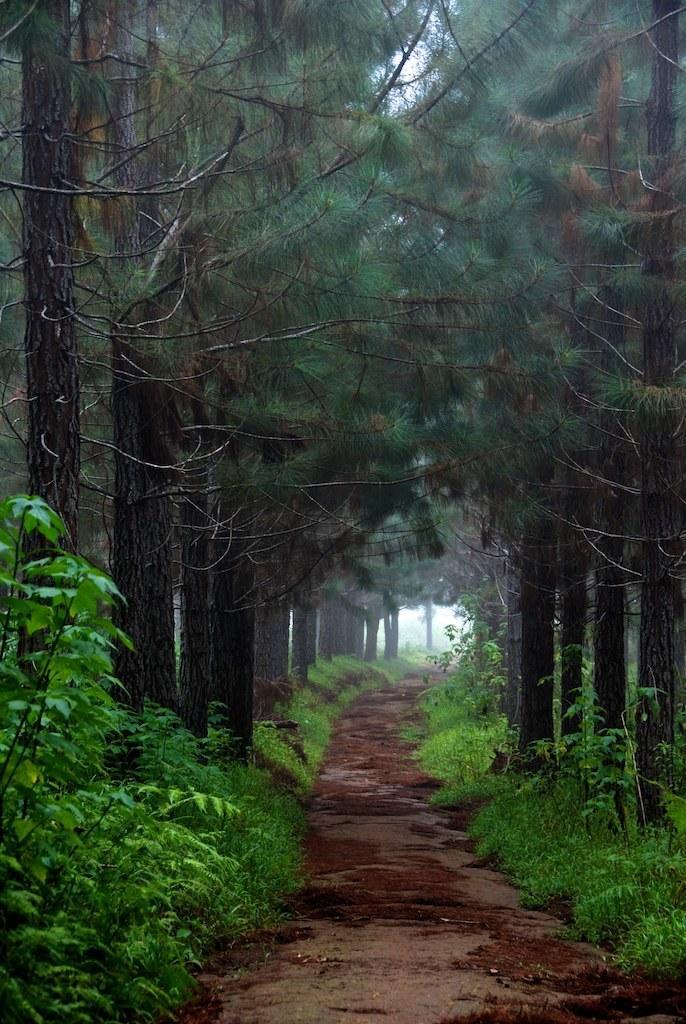How would you summarize this image in a sentence or two? This image is taken outdoors. At the bottom of the image there is a ground with grass and plants. At the top of the image there are many trees. 